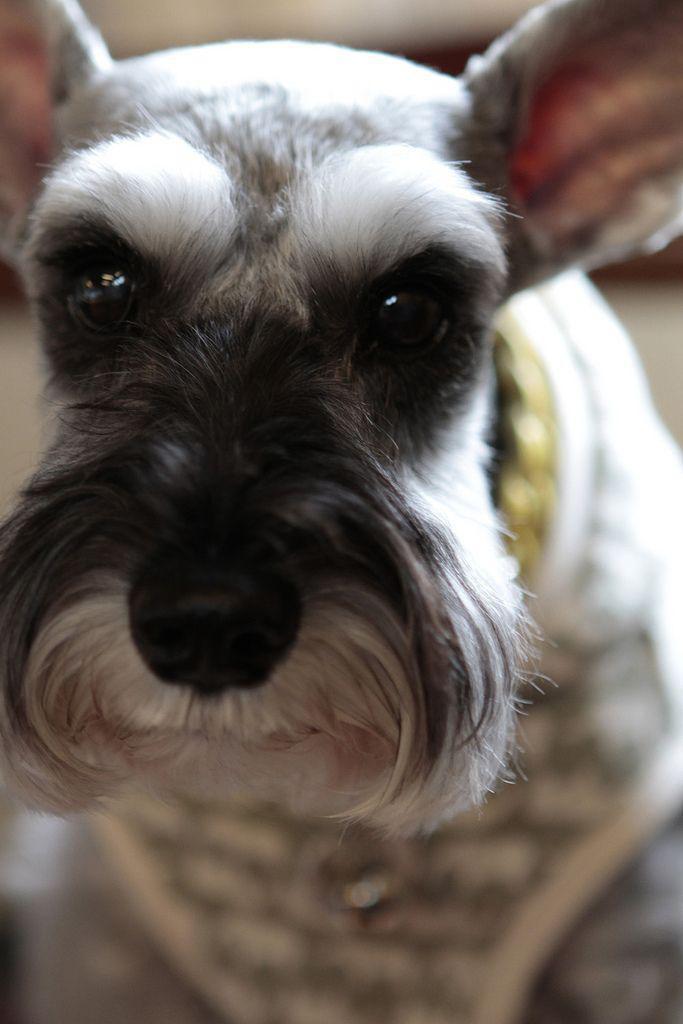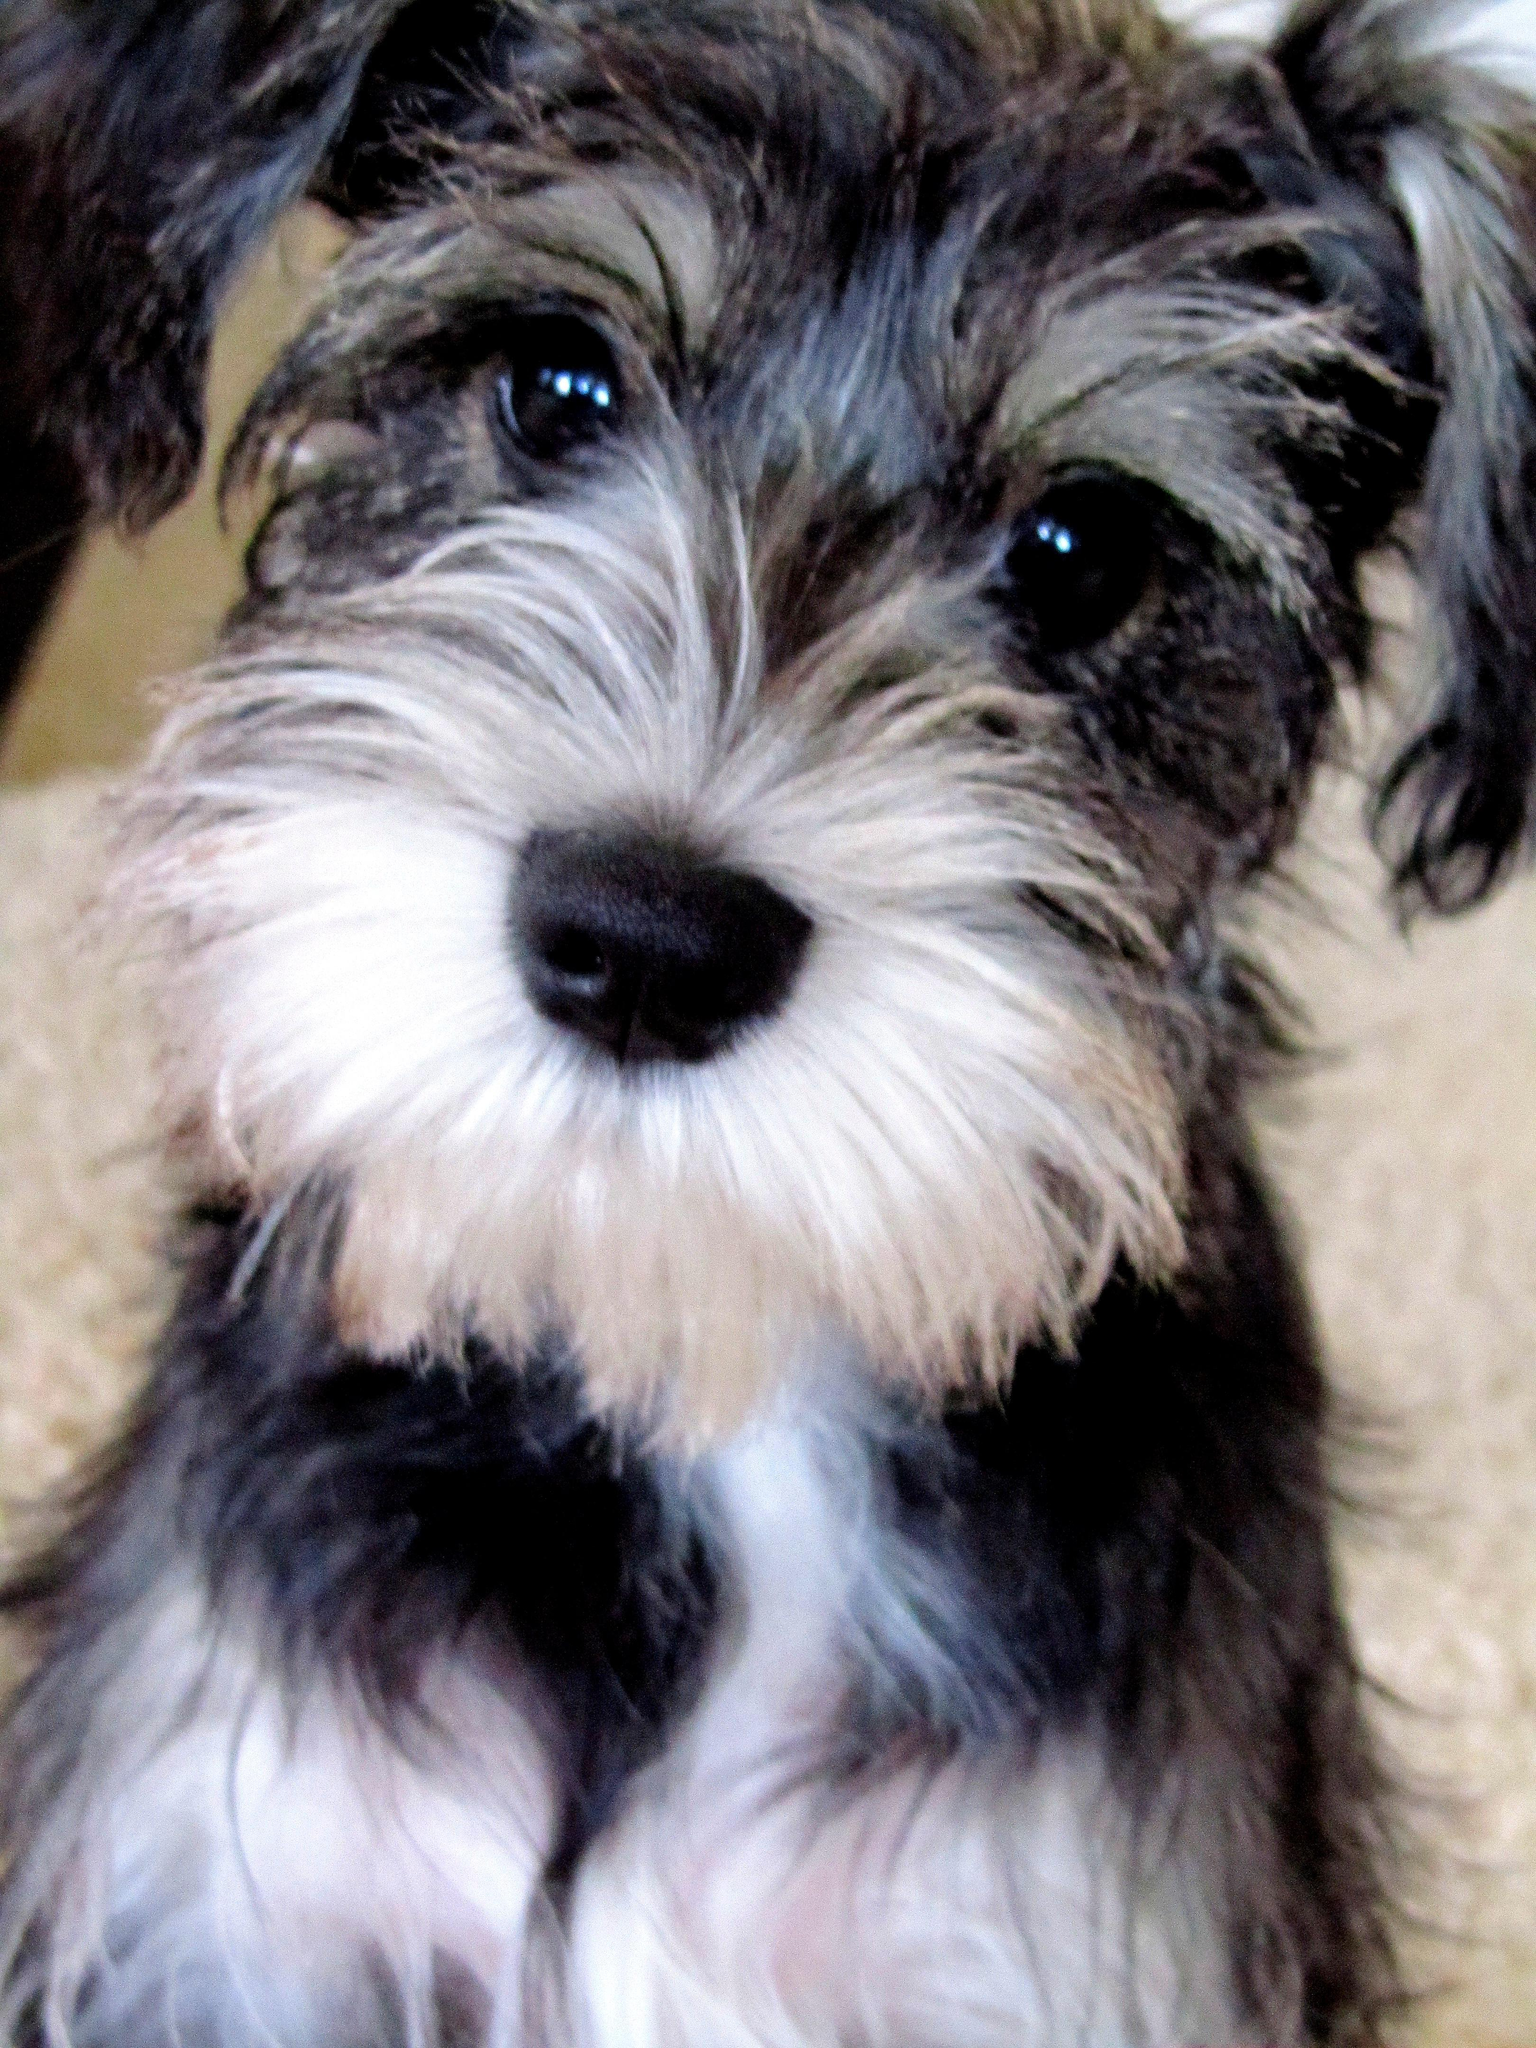The first image is the image on the left, the second image is the image on the right. Evaluate the accuracy of this statement regarding the images: "All dogs face directly forward, and all dogs have 'beards and mustaches' that are a different color from the rest of the fur on their faces.". Is it true? Answer yes or no. Yes. 